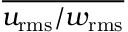Convert formula to latex. <formula><loc_0><loc_0><loc_500><loc_500>\overline { { u _ { r m s } / w _ { r m s } } }</formula> 